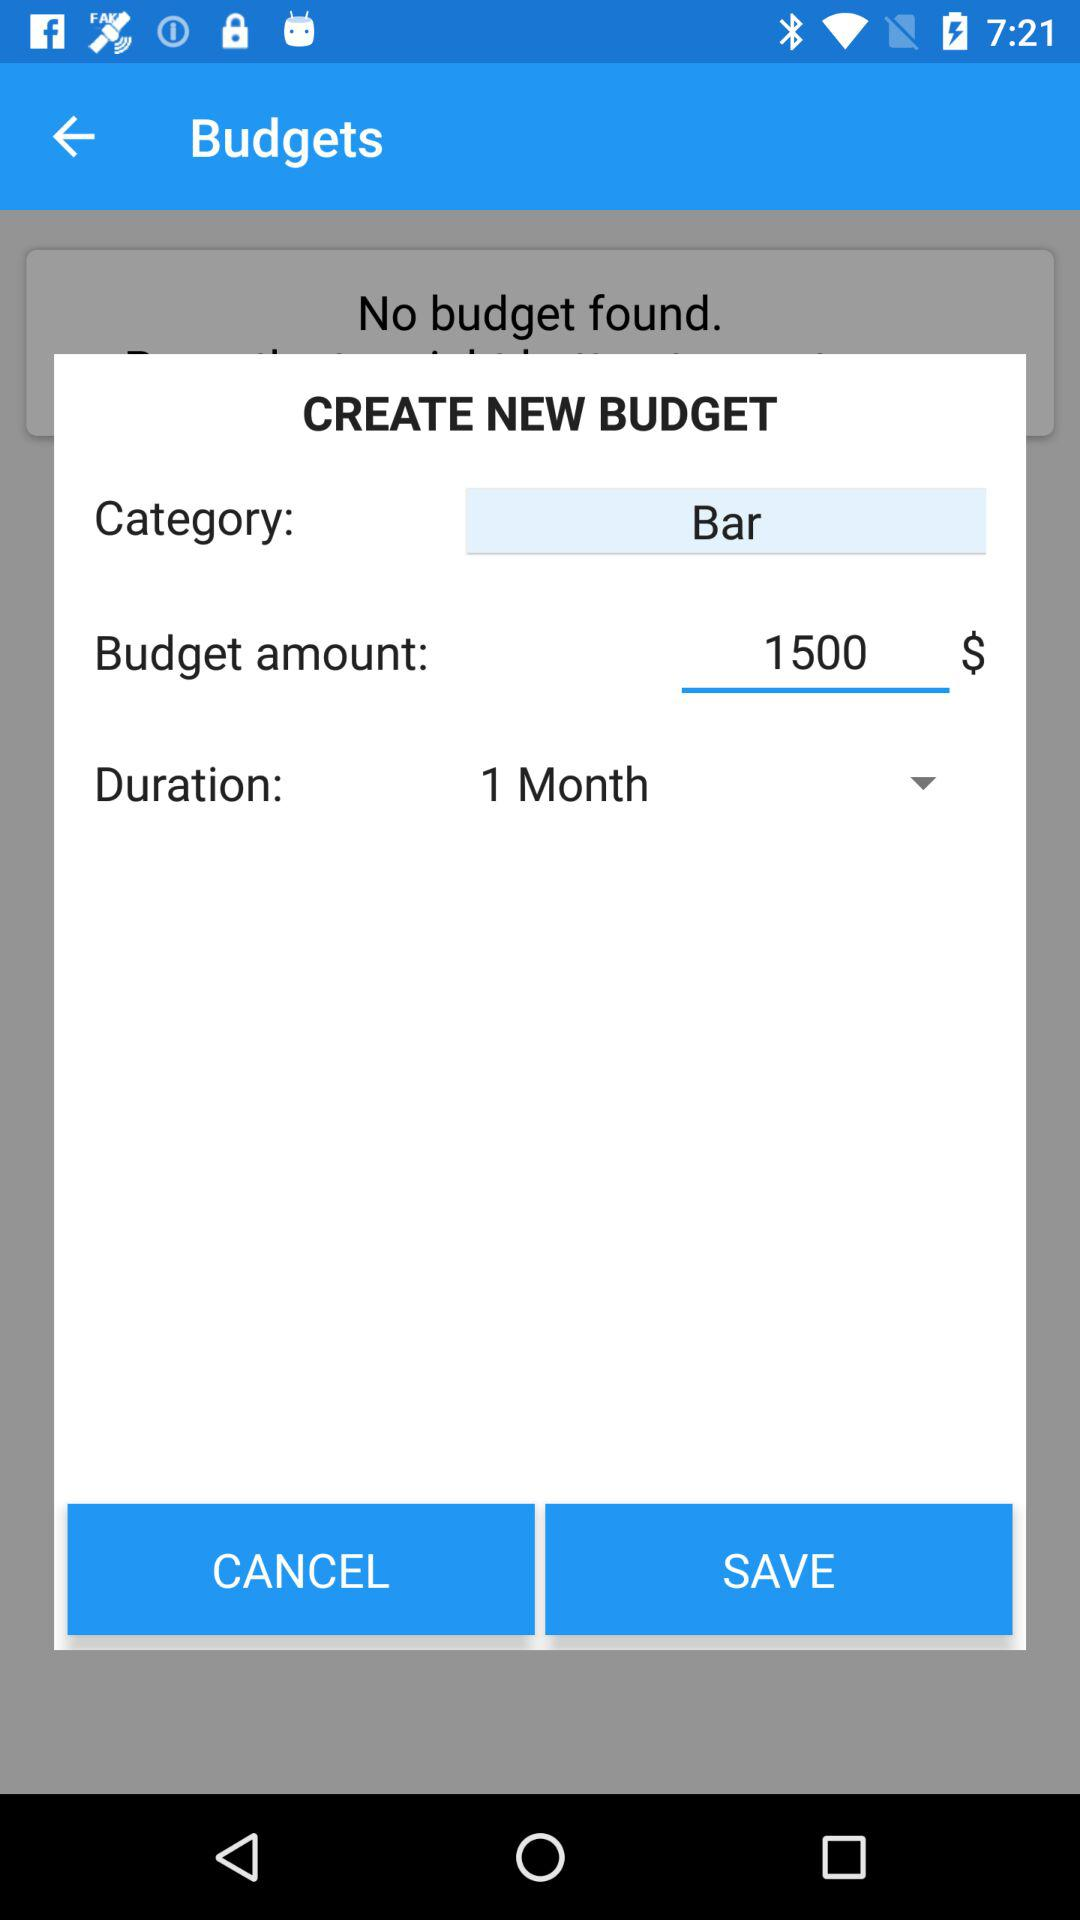What is the duration of the new budget?
Answer the question using a single word or phrase. 1 Month 